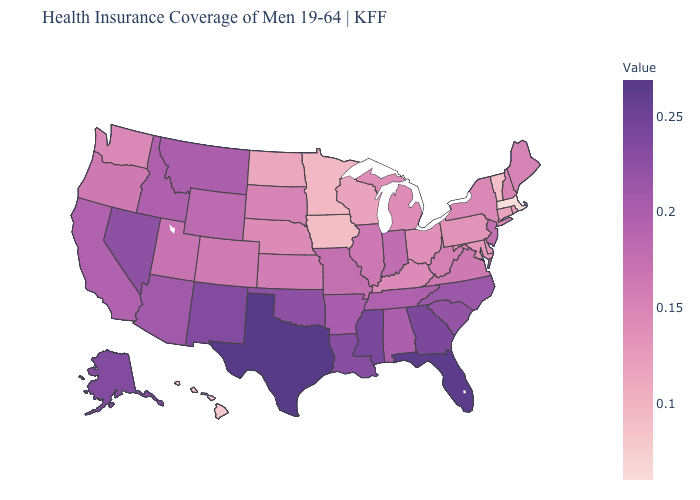Which states have the lowest value in the Northeast?
Be succinct. Massachusetts. Among the states that border Montana , which have the lowest value?
Give a very brief answer. North Dakota. Does Delaware have the lowest value in the South?
Give a very brief answer. Yes. 